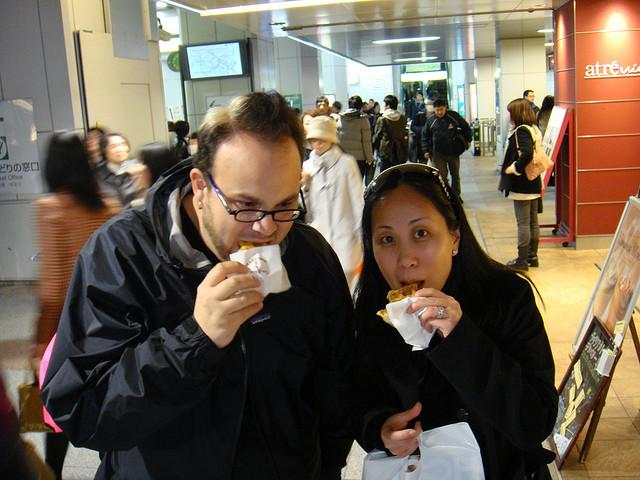Why did this couple take a break?

Choices:
A) hunger
B) bathroom
C) work rule
D) thirst hunger 